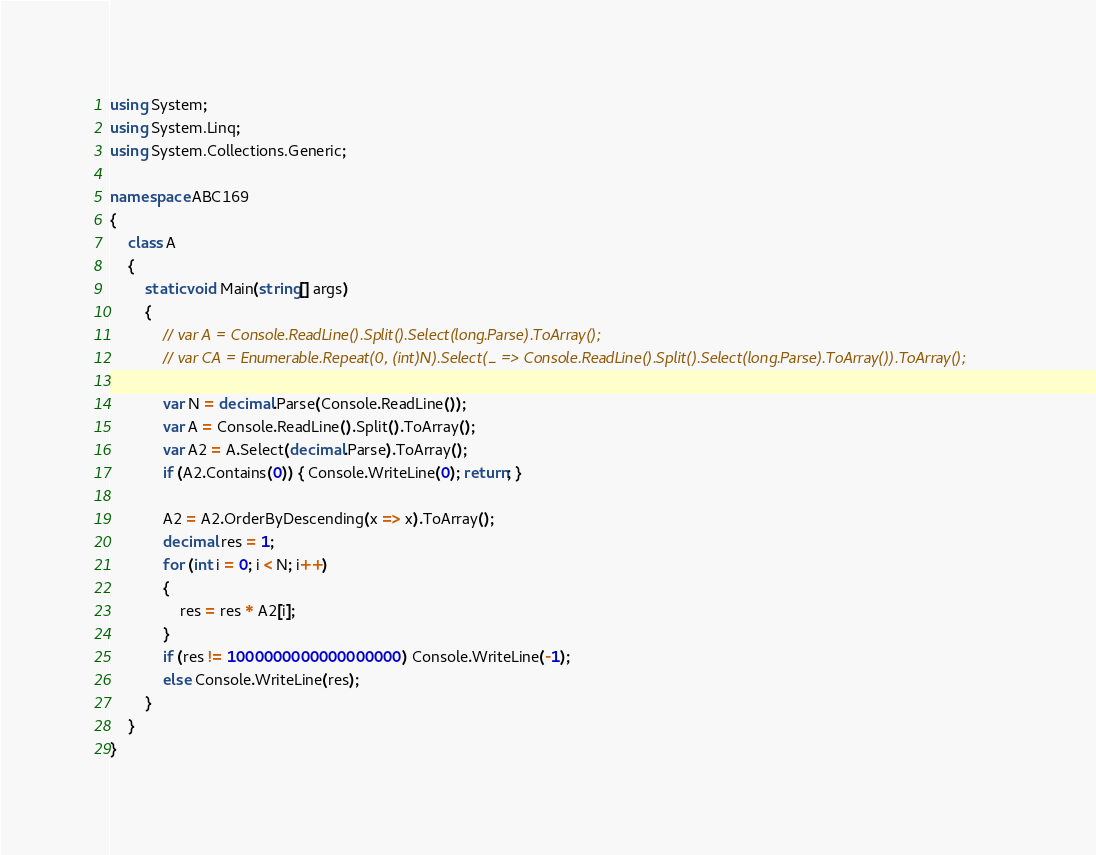<code> <loc_0><loc_0><loc_500><loc_500><_C#_>using System;
using System.Linq;
using System.Collections.Generic;

namespace ABC169
{
    class A
    {
        static void Main(string[] args)
        {
            // var A = Console.ReadLine().Split().Select(long.Parse).ToArray();
            // var CA = Enumerable.Repeat(0, (int)N).Select(_ => Console.ReadLine().Split().Select(long.Parse).ToArray()).ToArray();

            var N = decimal.Parse(Console.ReadLine());
            var A = Console.ReadLine().Split().ToArray();
            var A2 = A.Select(decimal.Parse).ToArray();
            if (A2.Contains(0)) { Console.WriteLine(0); return; }

            A2 = A2.OrderByDescending(x => x).ToArray();
            decimal res = 1;
            for (int i = 0; i < N; i++)
            {
                res = res * A2[i];
            }
            if (res != 1000000000000000000) Console.WriteLine(-1);
            else Console.WriteLine(res);
        }
    }
}
</code> 